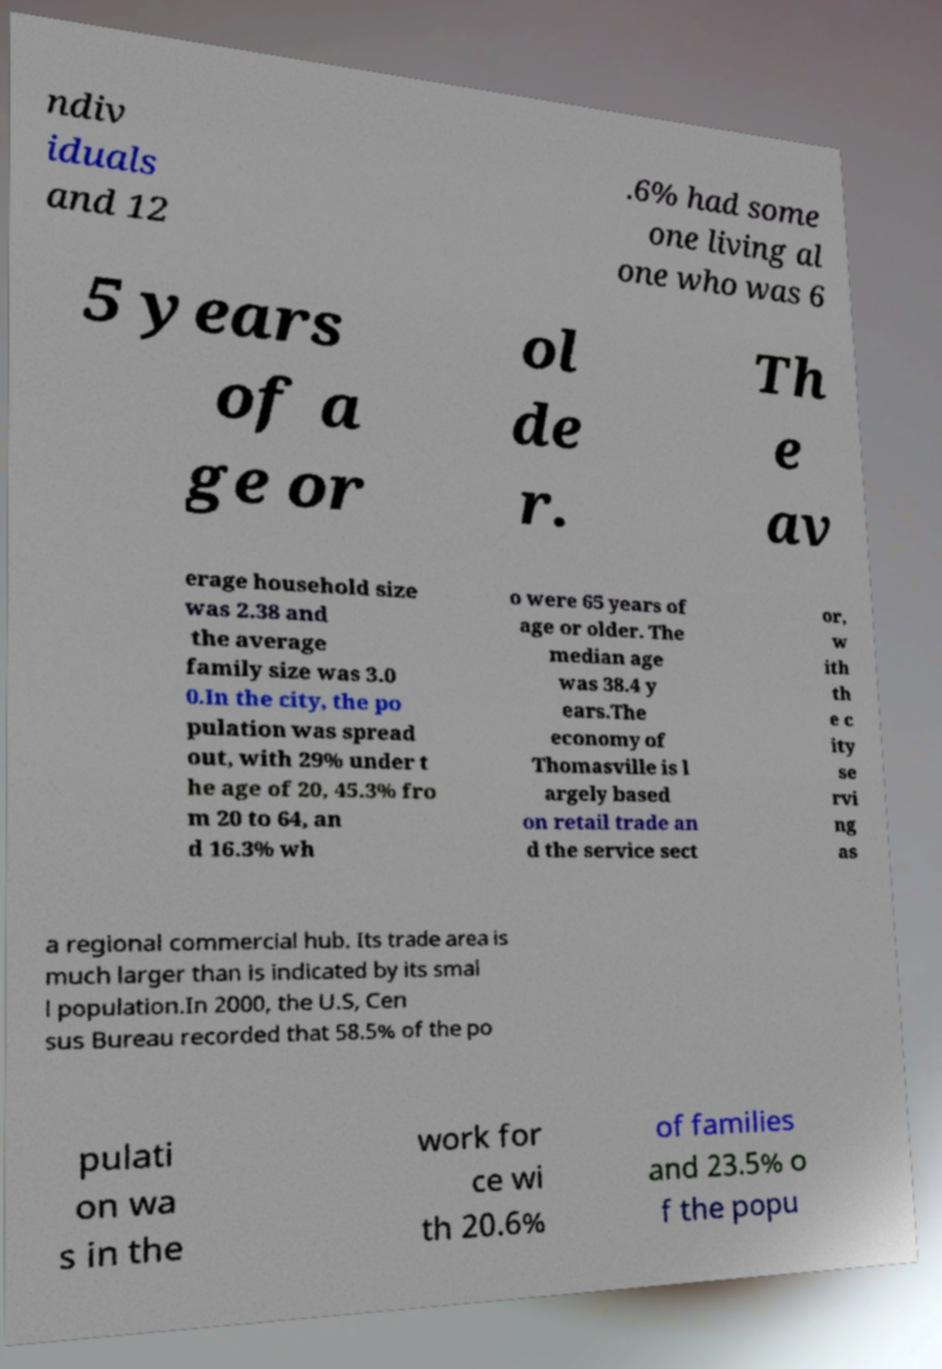Could you extract and type out the text from this image? ndiv iduals and 12 .6% had some one living al one who was 6 5 years of a ge or ol de r. Th e av erage household size was 2.38 and the average family size was 3.0 0.In the city, the po pulation was spread out, with 29% under t he age of 20, 45.3% fro m 20 to 64, an d 16.3% wh o were 65 years of age or older. The median age was 38.4 y ears.The economy of Thomasville is l argely based on retail trade an d the service sect or, w ith th e c ity se rvi ng as a regional commercial hub. Its trade area is much larger than is indicated by its smal l population.In 2000, the U.S, Cen sus Bureau recorded that 58.5% of the po pulati on wa s in the work for ce wi th 20.6% of families and 23.5% o f the popu 